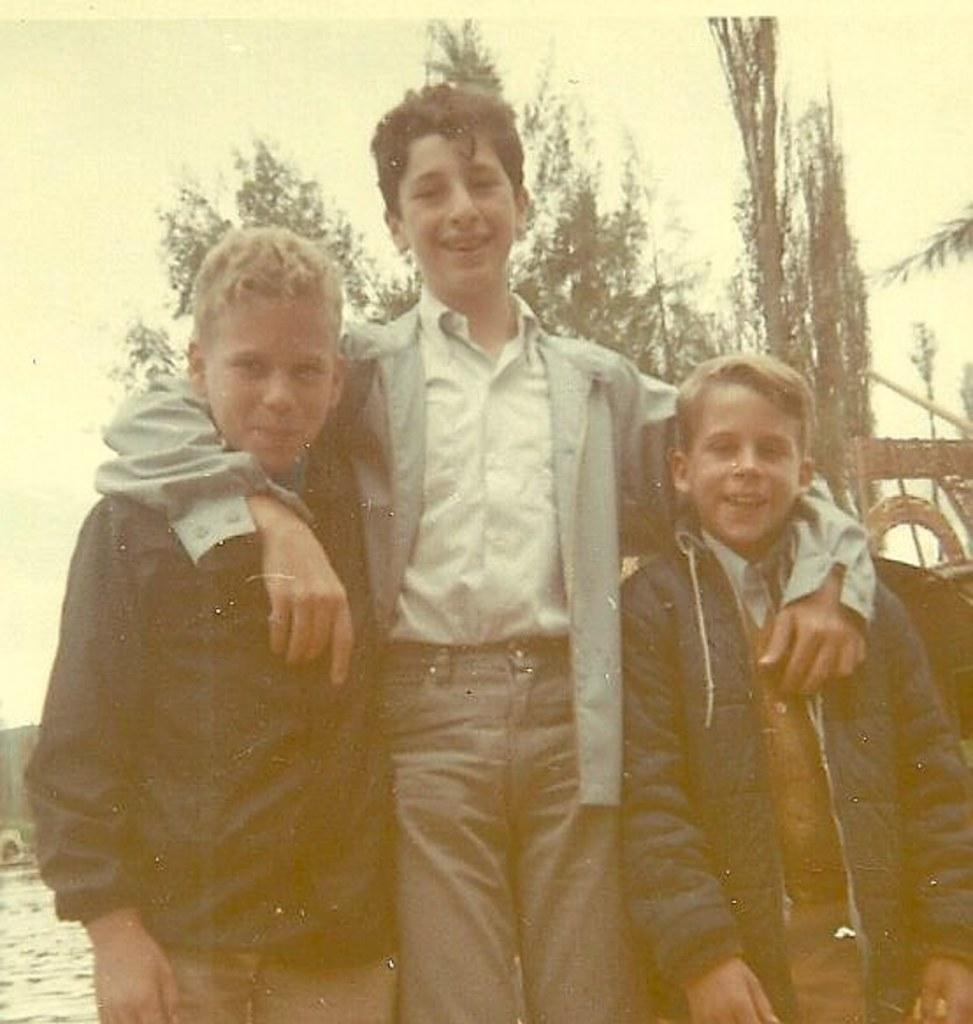How many kids are in the image? There are three kids in the image. What are the kids doing in the image? The kids are standing with smiles on their faces. What can be seen in the background of the image? There are trees visible behind the kids. What type of nail is being used by the kids in the image? There is no nail present in the image. How many stars can be seen in the sky in the image? The image does not show the sky, so it is not possible to determine if there are any stars visible. 